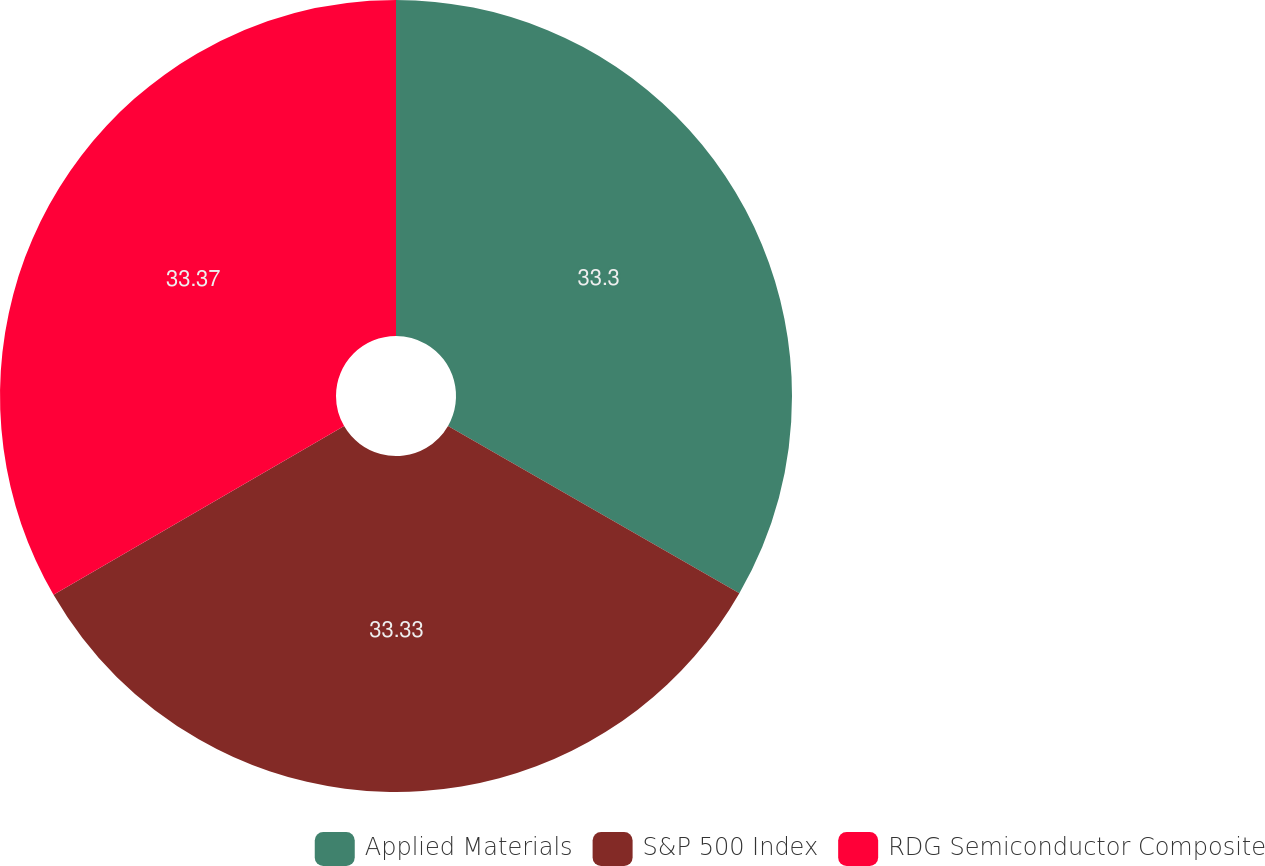<chart> <loc_0><loc_0><loc_500><loc_500><pie_chart><fcel>Applied Materials<fcel>S&P 500 Index<fcel>RDG Semiconductor Composite<nl><fcel>33.3%<fcel>33.33%<fcel>33.37%<nl></chart> 